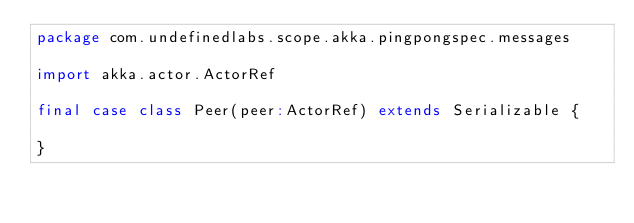Convert code to text. <code><loc_0><loc_0><loc_500><loc_500><_Scala_>package com.undefinedlabs.scope.akka.pingpongspec.messages

import akka.actor.ActorRef

final case class Peer(peer:ActorRef) extends Serializable {

}
</code> 